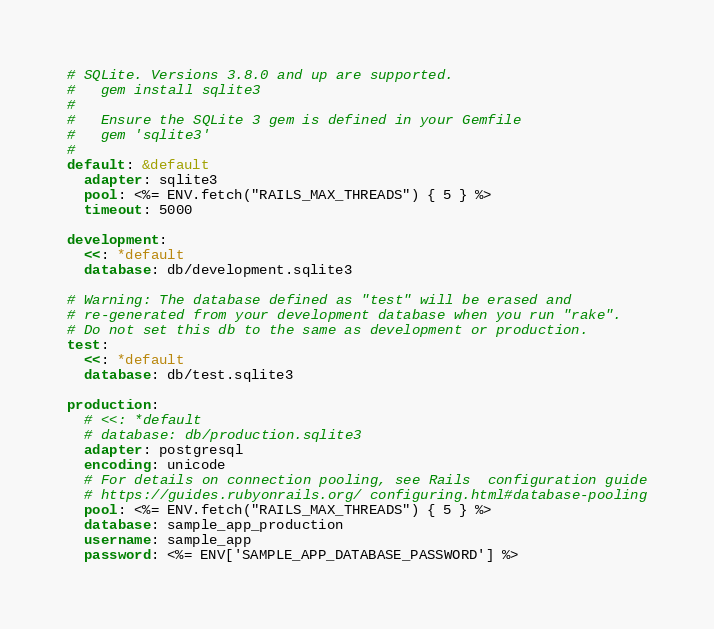<code> <loc_0><loc_0><loc_500><loc_500><_YAML_># SQLite. Versions 3.8.0 and up are supported.
#   gem install sqlite3
#
#   Ensure the SQLite 3 gem is defined in your Gemfile
#   gem 'sqlite3'
#
default: &default
  adapter: sqlite3
  pool: <%= ENV.fetch("RAILS_MAX_THREADS") { 5 } %>
  timeout: 5000

development:
  <<: *default
  database: db/development.sqlite3

# Warning: The database defined as "test" will be erased and
# re-generated from your development database when you run "rake".
# Do not set this db to the same as development or production.
test:
  <<: *default
  database: db/test.sqlite3

production:
  # <<: *default
  # database: db/production.sqlite3
  adapter: postgresql
  encoding: unicode
  # For details on connection pooling, see Rails  configuration guide
  # https://guides.rubyonrails.org/ configuring.html#database-pooling
  pool: <%= ENV.fetch("RAILS_MAX_THREADS") { 5 } %>
  database: sample_app_production
  username: sample_app
  password: <%= ENV['SAMPLE_APP_DATABASE_PASSWORD'] %></code> 